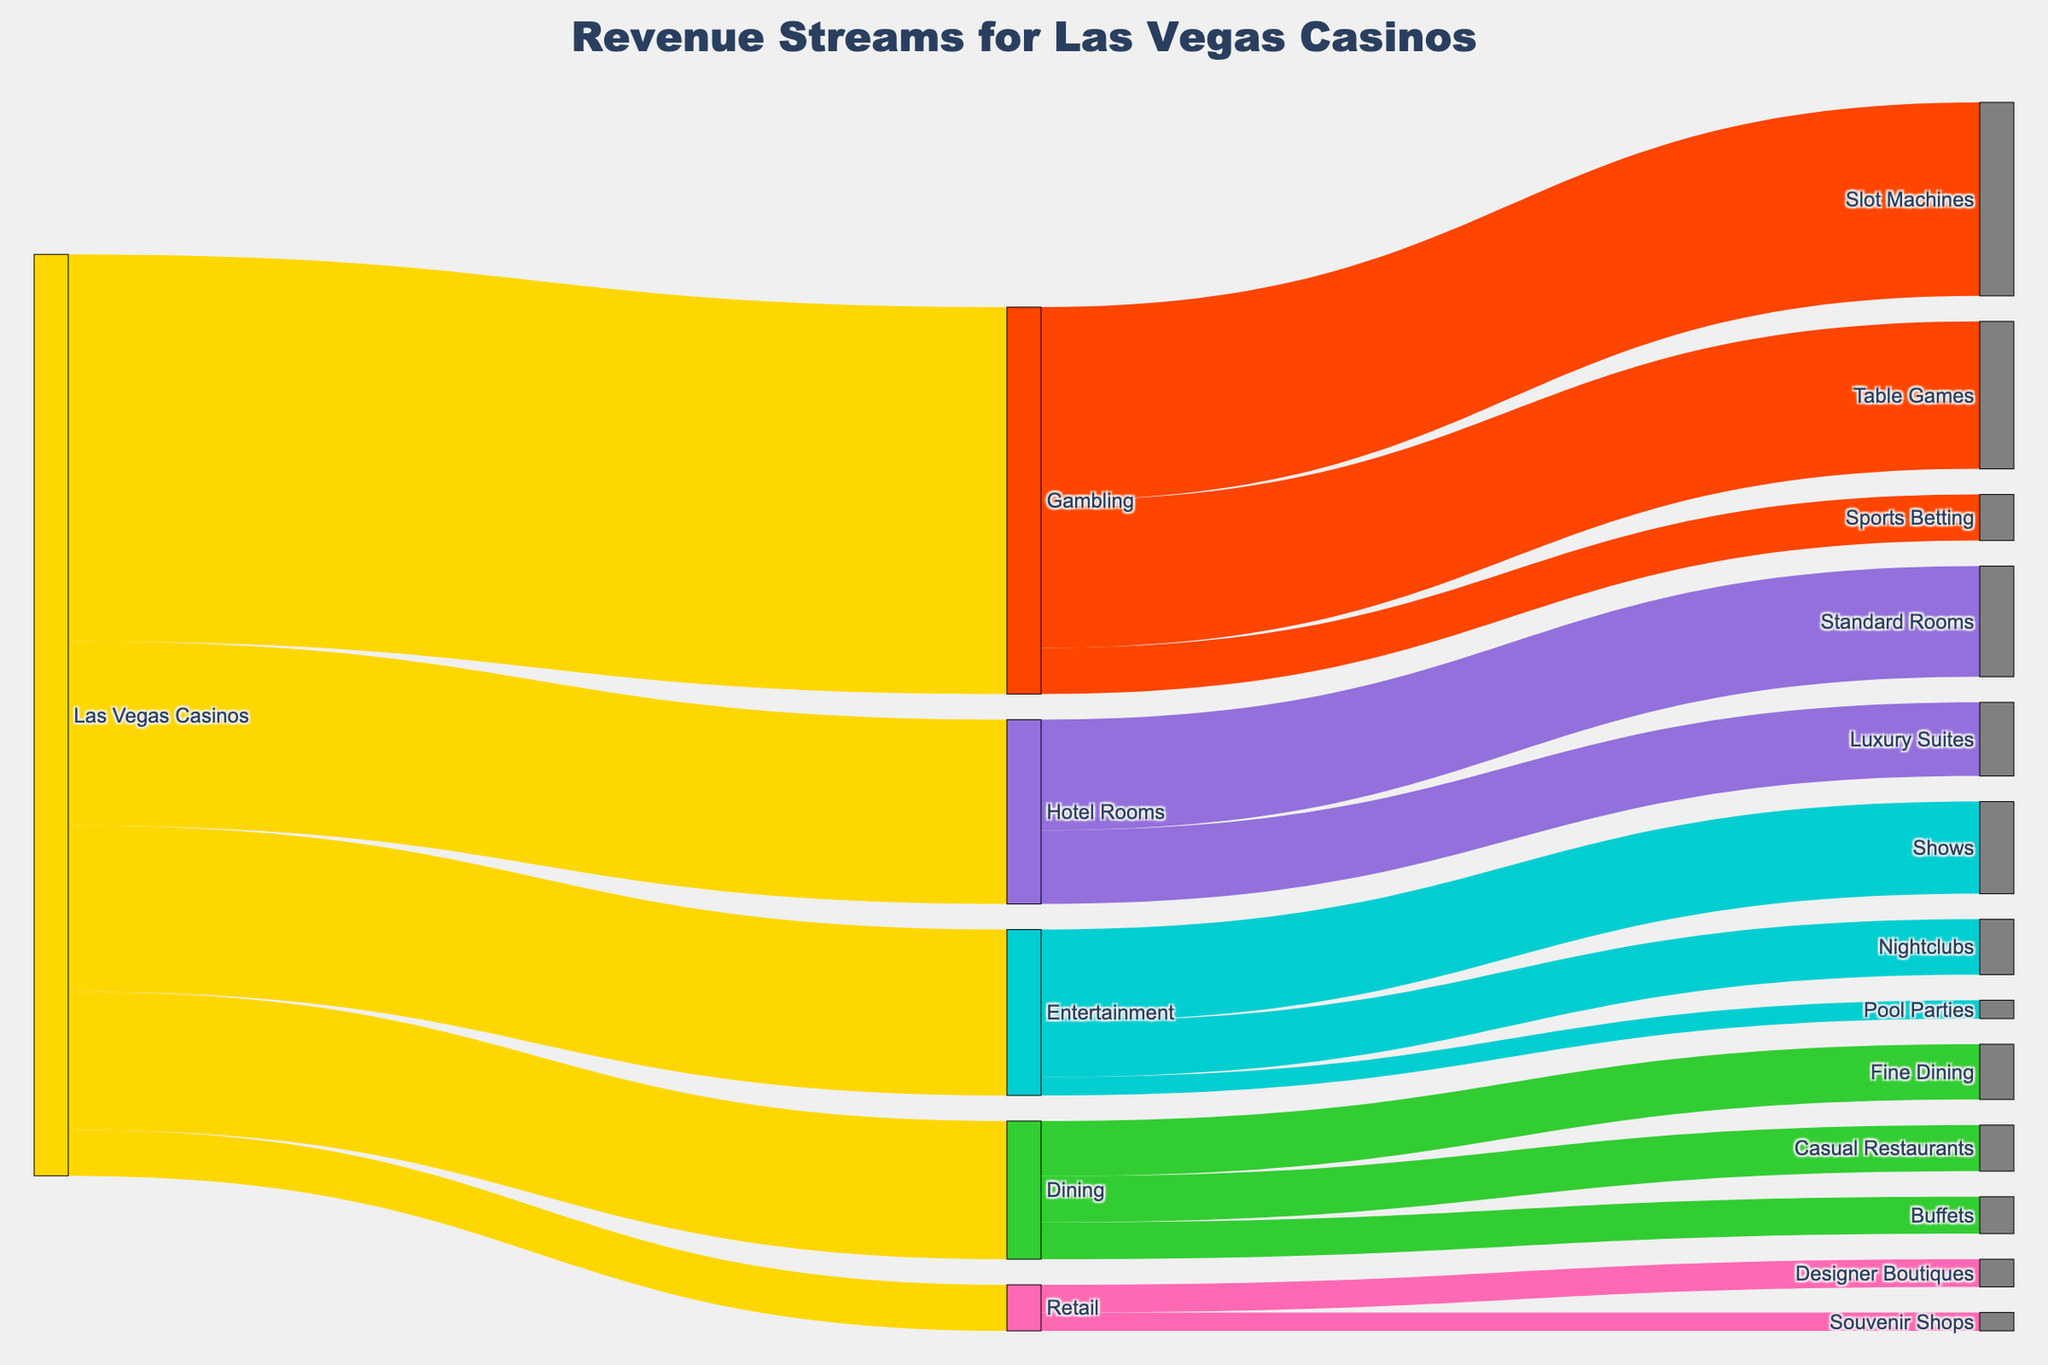What are the main revenue streams for Las Vegas Casinos? The main revenue streams can be seen at the first level of the diagram where "Las Vegas Casinos" divides into five streams: Gambling, Entertainment, Dining, Hotel Rooms, and Retail.
Answer: Gambling, Entertainment, Dining, Hotel Rooms, Retail Which category under Gambling generates the most revenue? By following the branch under Gambling, we see that Slot Machines generate the most revenue with a value of 2100.
Answer: Slot Machines How much total revenue do "Entertainment" and "Dining" generate together? The revenue for Entertainment is 1800 and for Dining is 1500. Adding these together, 1800 + 1500 = 3300.
Answer: 3300 Which category under Hotel Rooms has higher revenue, Luxury Suites or Standard Rooms? By following the branch under Hotel Rooms, we see that Standard Rooms generate more revenue (1200) compared to Luxury Suites (800).
Answer: Standard Rooms How much more revenue do Shows generate compared to Pool Parties? The revenue for Shows is 1000, and for Pool Parties is 200. Subtracting these, 1000 - 200 = 800.
Answer: 800 What is the total revenue generated by all categories under "Retail"? The categories under Retail are Designer Boutiques (300) and Souvenir Shops (200). Adding these together, 300 + 200 = 500.
Answer: 500 Which category under Dining has the least revenue? By following the branches under Dining, we see that Buffets have the least revenue with a value of 400.
Answer: Buffets Which category, gambling through Table Games or entertainment through Nightclubs, generates more revenue? The revenue for Table Games under Gambling is 1600, and for Nightclubs under Entertainment is 600. Table Games generates more revenue.
Answer: Table Games What proportion of the Gambling revenue is derived from Table Games? The total Gambling revenue is 4200, and Table Games generate 1600. The proportion is 1600/4200 which simplifies to approximately 38.1%.
Answer: 38.1% What is the overall revenue contributed by Gambling and Hotel Rooms combined? The revenue for Gambling is 4200 and for Hotel Rooms is 2000. Adding these together, 4200 + 2000 = 6200.
Answer: 6200 